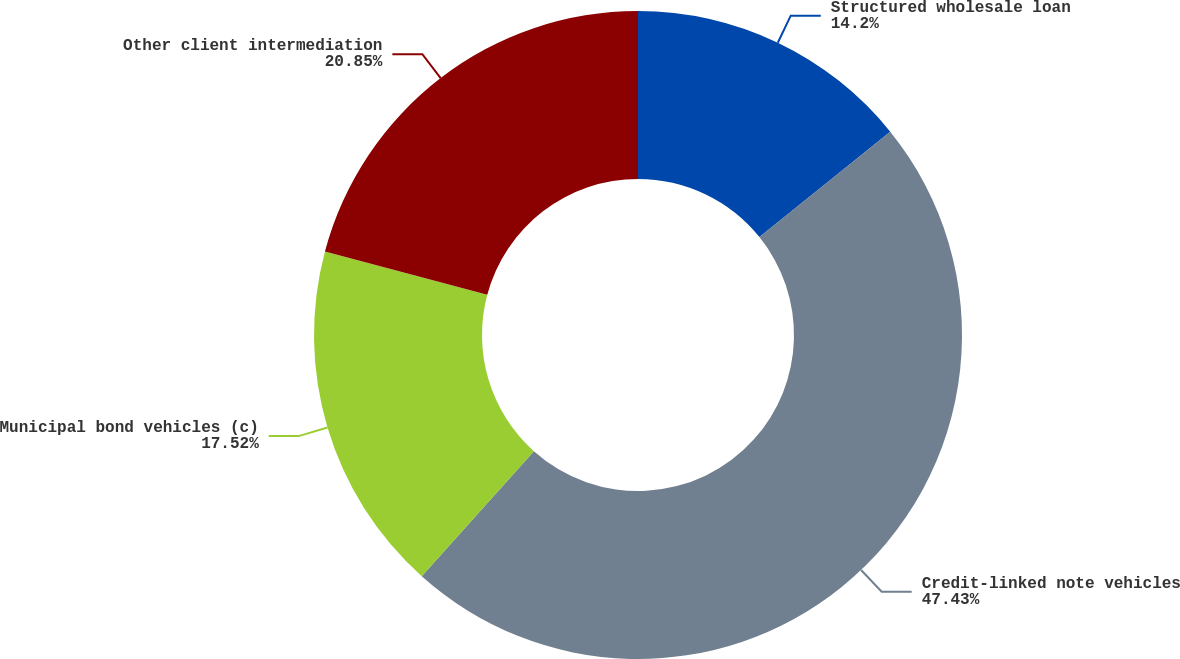<chart> <loc_0><loc_0><loc_500><loc_500><pie_chart><fcel>Structured wholesale loan<fcel>Credit-linked note vehicles<fcel>Municipal bond vehicles (c)<fcel>Other client intermediation<nl><fcel>14.2%<fcel>47.43%<fcel>17.52%<fcel>20.85%<nl></chart> 